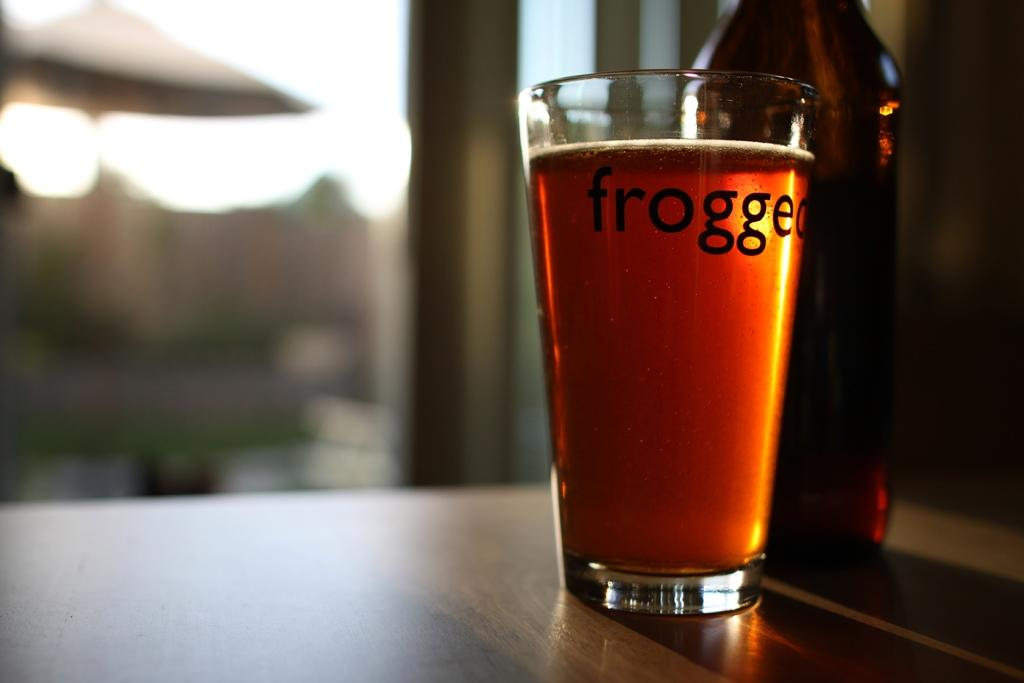<image>
Relay a brief, clear account of the picture shown. A full glass with a label frogged on it 